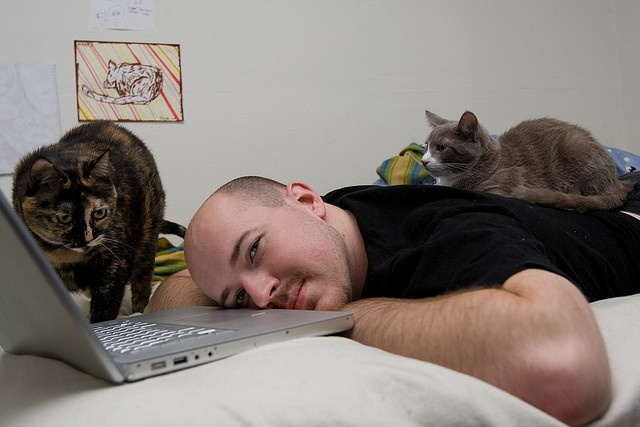Describe the objects in this image and their specific colors. I can see people in darkgray, black, gray, lightpink, and tan tones, bed in darkgray, lightgray, and gray tones, laptop in darkgray, gray, and black tones, cat in darkgray, black, maroon, and gray tones, and cat in darkgray, black, and gray tones in this image. 